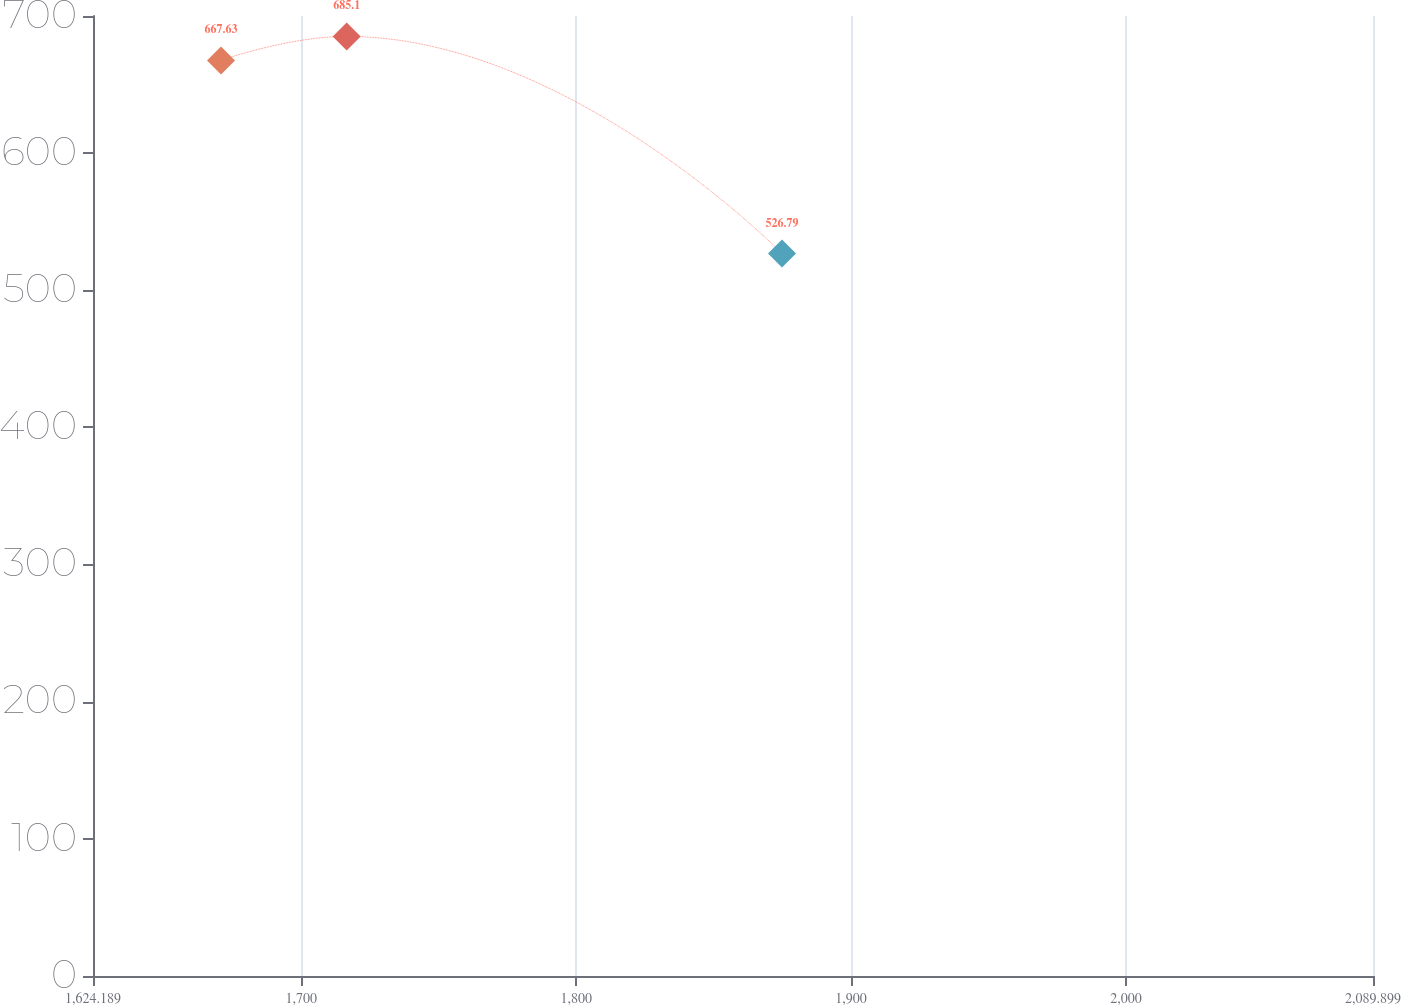Convert chart to OTSL. <chart><loc_0><loc_0><loc_500><loc_500><line_chart><ecel><fcel>Unnamed: 1<nl><fcel>1670.76<fcel>667.63<nl><fcel>1716.49<fcel>685.1<nl><fcel>1874.88<fcel>526.79<nl><fcel>2090.74<fcel>702.57<nl><fcel>2136.47<fcel>573.16<nl></chart> 